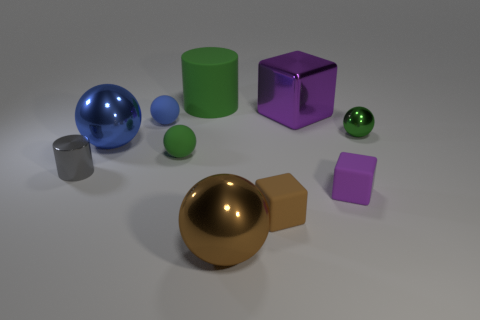Subtract all large metal balls. How many balls are left? 3 Subtract 0 cyan blocks. How many objects are left? 10 Subtract all cylinders. How many objects are left? 8 Subtract 1 cubes. How many cubes are left? 2 Subtract all gray balls. Subtract all brown blocks. How many balls are left? 5 Subtract all gray cylinders. How many purple blocks are left? 2 Subtract all green rubber things. Subtract all small balls. How many objects are left? 5 Add 6 brown objects. How many brown objects are left? 8 Add 3 small cyan matte balls. How many small cyan matte balls exist? 3 Subtract all gray cylinders. How many cylinders are left? 1 